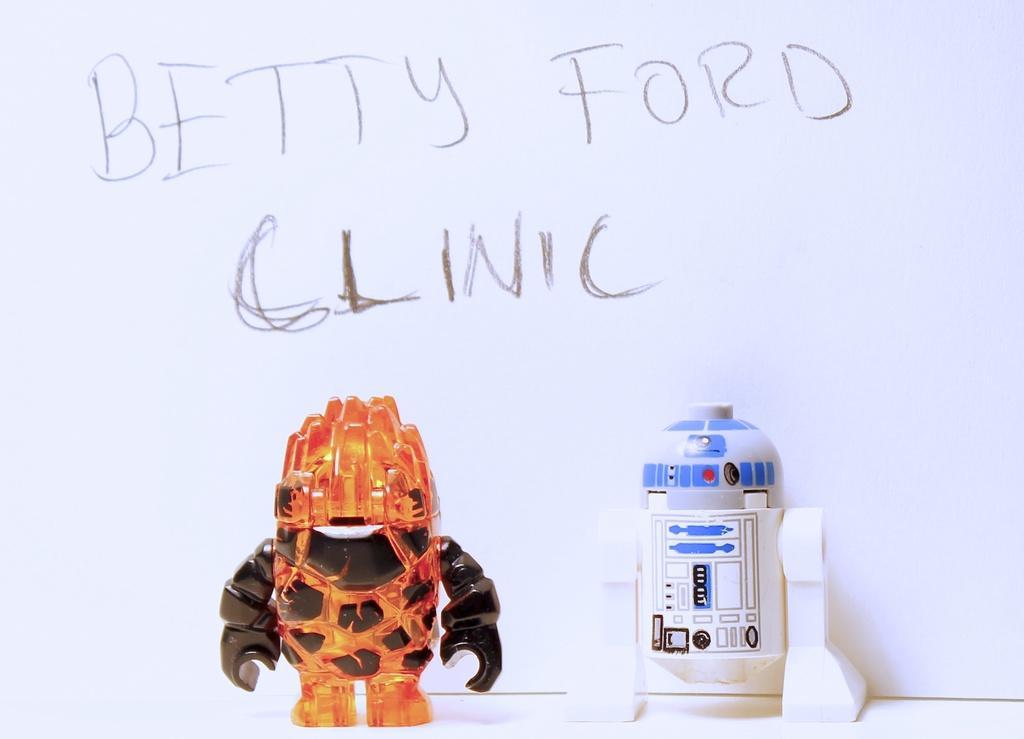Please provide a concise description of this image. In this image we can see two toys placed on the surface, In the background, we can see a wall with some text on it. 